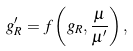Convert formula to latex. <formula><loc_0><loc_0><loc_500><loc_500>g _ { R } ^ { \prime } = f \left ( g _ { R } , \frac { \mu } { \mu ^ { \prime } } \right ) ,</formula> 